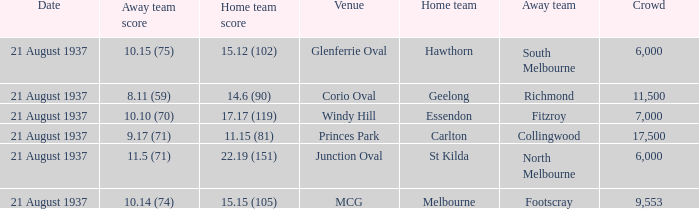Where did Richmond play? Corio Oval. 